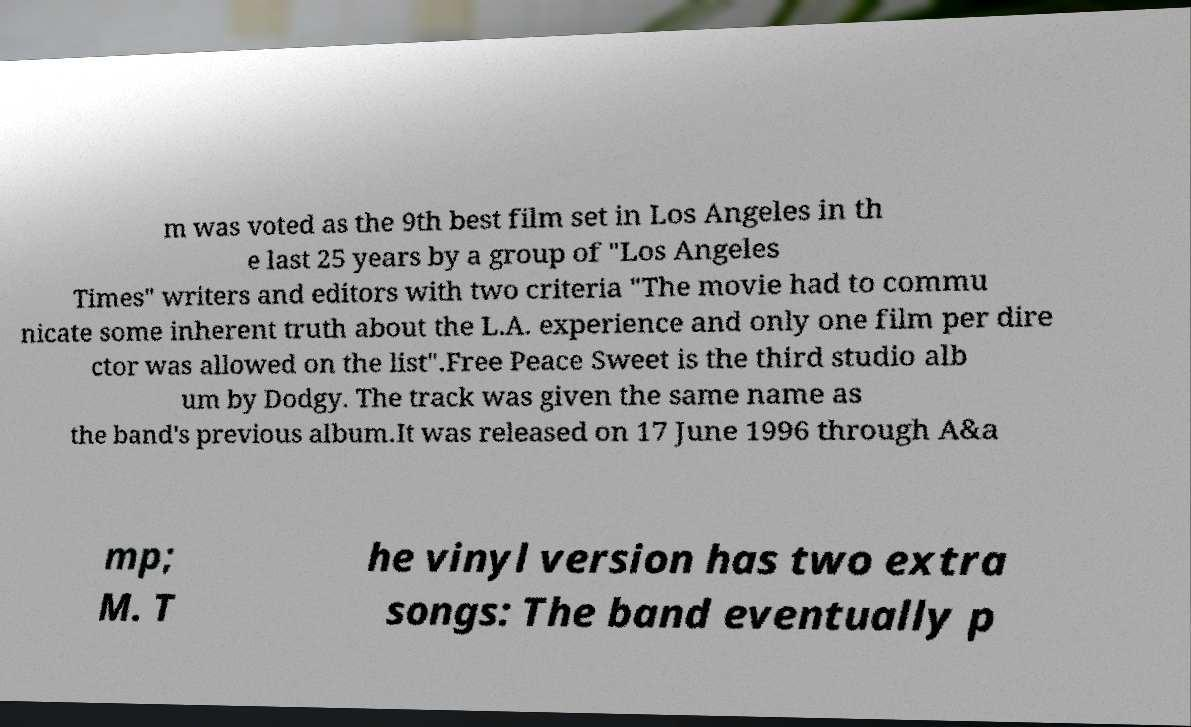What messages or text are displayed in this image? I need them in a readable, typed format. m was voted as the 9th best film set in Los Angeles in th e last 25 years by a group of "Los Angeles Times" writers and editors with two criteria "The movie had to commu nicate some inherent truth about the L.A. experience and only one film per dire ctor was allowed on the list".Free Peace Sweet is the third studio alb um by Dodgy. The track was given the same name as the band's previous album.It was released on 17 June 1996 through A&a mp; M. T he vinyl version has two extra songs: The band eventually p 